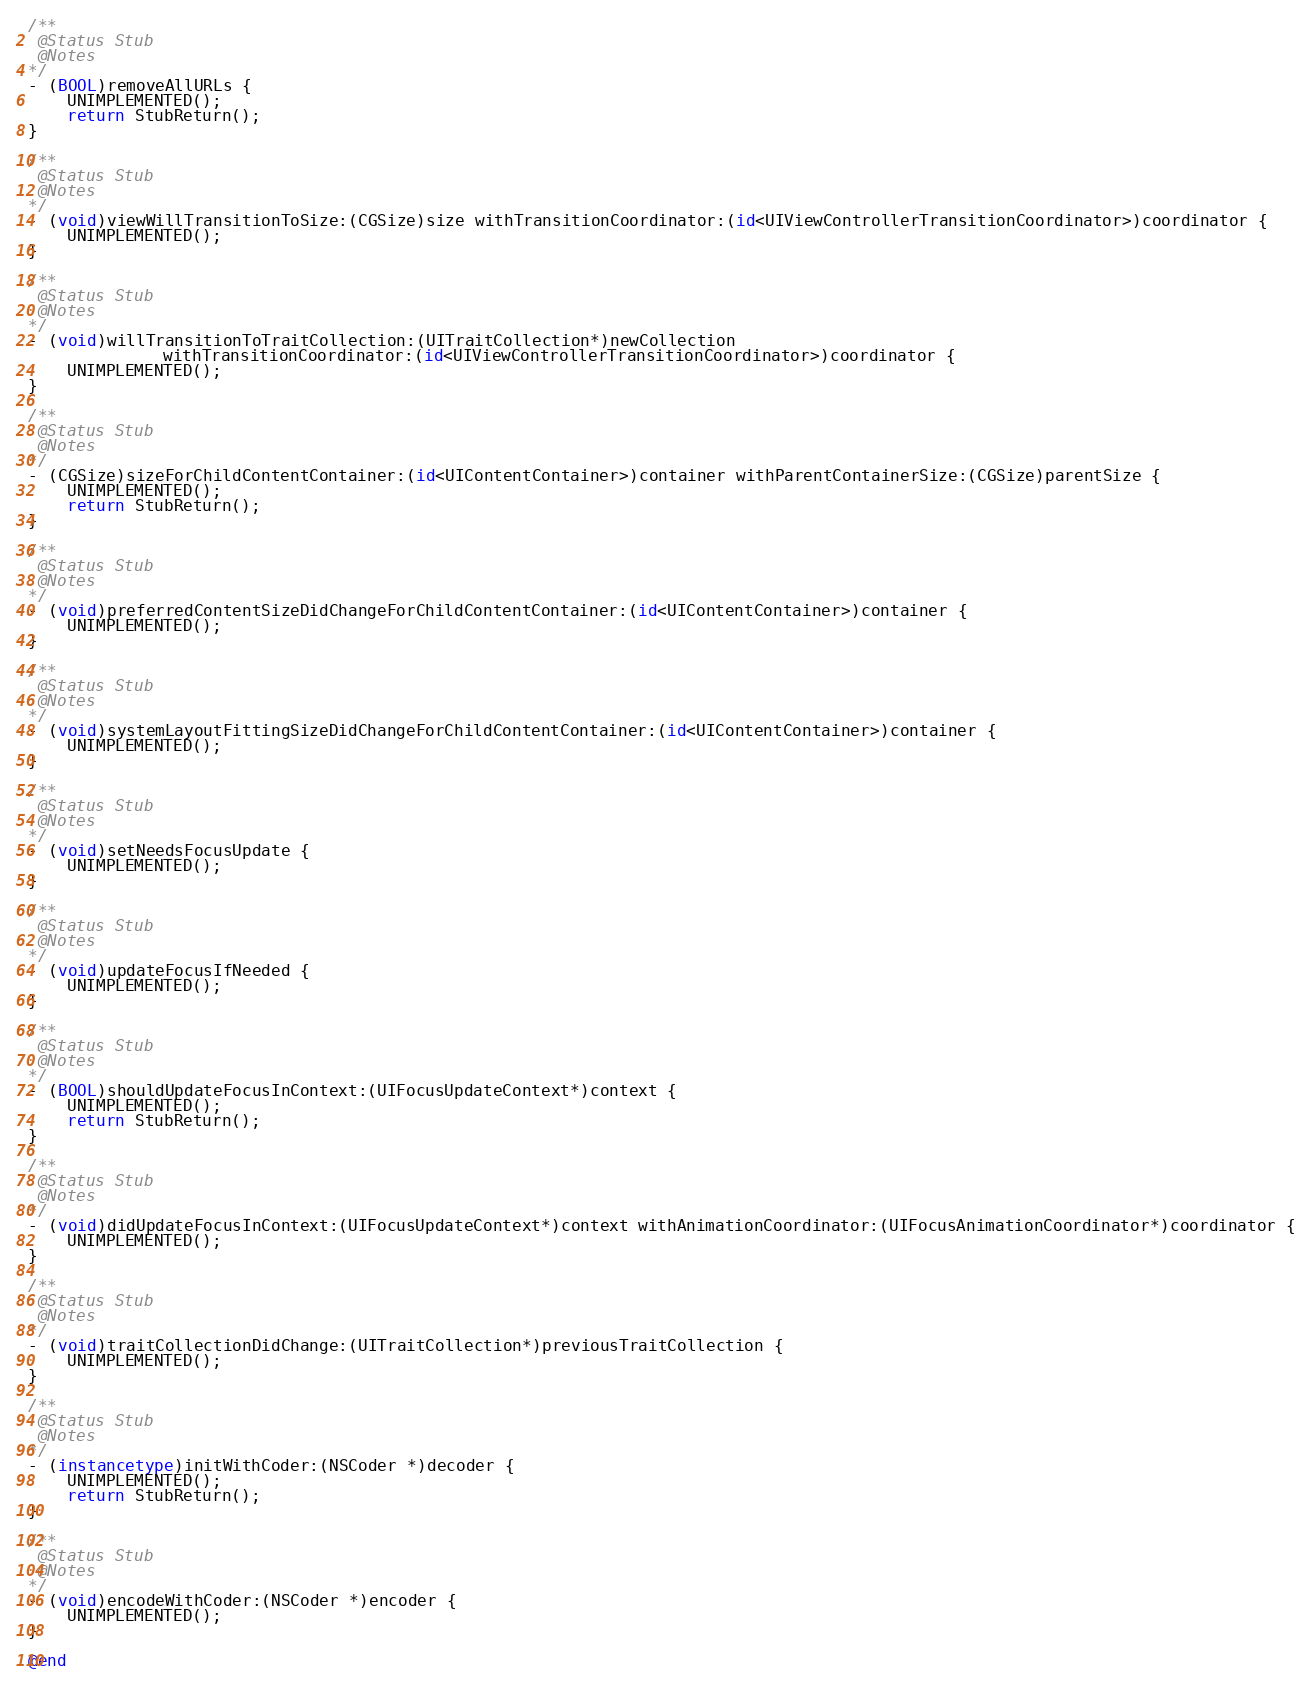Convert code to text. <code><loc_0><loc_0><loc_500><loc_500><_ObjectiveC_>
/**
 @Status Stub
 @Notes
*/
- (BOOL)removeAllURLs {
    UNIMPLEMENTED();
    return StubReturn();
}

/**
 @Status Stub
 @Notes
*/
- (void)viewWillTransitionToSize:(CGSize)size withTransitionCoordinator:(id<UIViewControllerTransitionCoordinator>)coordinator {
    UNIMPLEMENTED();
}

/**
 @Status Stub
 @Notes
*/
- (void)willTransitionToTraitCollection:(UITraitCollection*)newCollection
              withTransitionCoordinator:(id<UIViewControllerTransitionCoordinator>)coordinator {
    UNIMPLEMENTED();
}

/**
 @Status Stub
 @Notes
*/
- (CGSize)sizeForChildContentContainer:(id<UIContentContainer>)container withParentContainerSize:(CGSize)parentSize {
    UNIMPLEMENTED();
    return StubReturn();
}

/**
 @Status Stub
 @Notes
*/
- (void)preferredContentSizeDidChangeForChildContentContainer:(id<UIContentContainer>)container {
    UNIMPLEMENTED();
}

/**
 @Status Stub
 @Notes
*/
- (void)systemLayoutFittingSizeDidChangeForChildContentContainer:(id<UIContentContainer>)container {
    UNIMPLEMENTED();
}

/**
 @Status Stub
 @Notes
*/
- (void)setNeedsFocusUpdate {
    UNIMPLEMENTED();
}

/**
 @Status Stub
 @Notes
*/
- (void)updateFocusIfNeeded {
    UNIMPLEMENTED();
}

/**
 @Status Stub
 @Notes
*/
- (BOOL)shouldUpdateFocusInContext:(UIFocusUpdateContext*)context {
    UNIMPLEMENTED();
    return StubReturn();
}

/**
 @Status Stub
 @Notes
*/
- (void)didUpdateFocusInContext:(UIFocusUpdateContext*)context withAnimationCoordinator:(UIFocusAnimationCoordinator*)coordinator {
    UNIMPLEMENTED();
}

/**
 @Status Stub
 @Notes
*/
- (void)traitCollectionDidChange:(UITraitCollection*)previousTraitCollection {
    UNIMPLEMENTED();
}

/**
 @Status Stub
 @Notes
*/
- (instancetype)initWithCoder:(NSCoder *)decoder {
    UNIMPLEMENTED();
    return StubReturn();
}

/**
 @Status Stub
 @Notes
*/
- (void)encodeWithCoder:(NSCoder *)encoder {
    UNIMPLEMENTED();
}

@end
</code> 